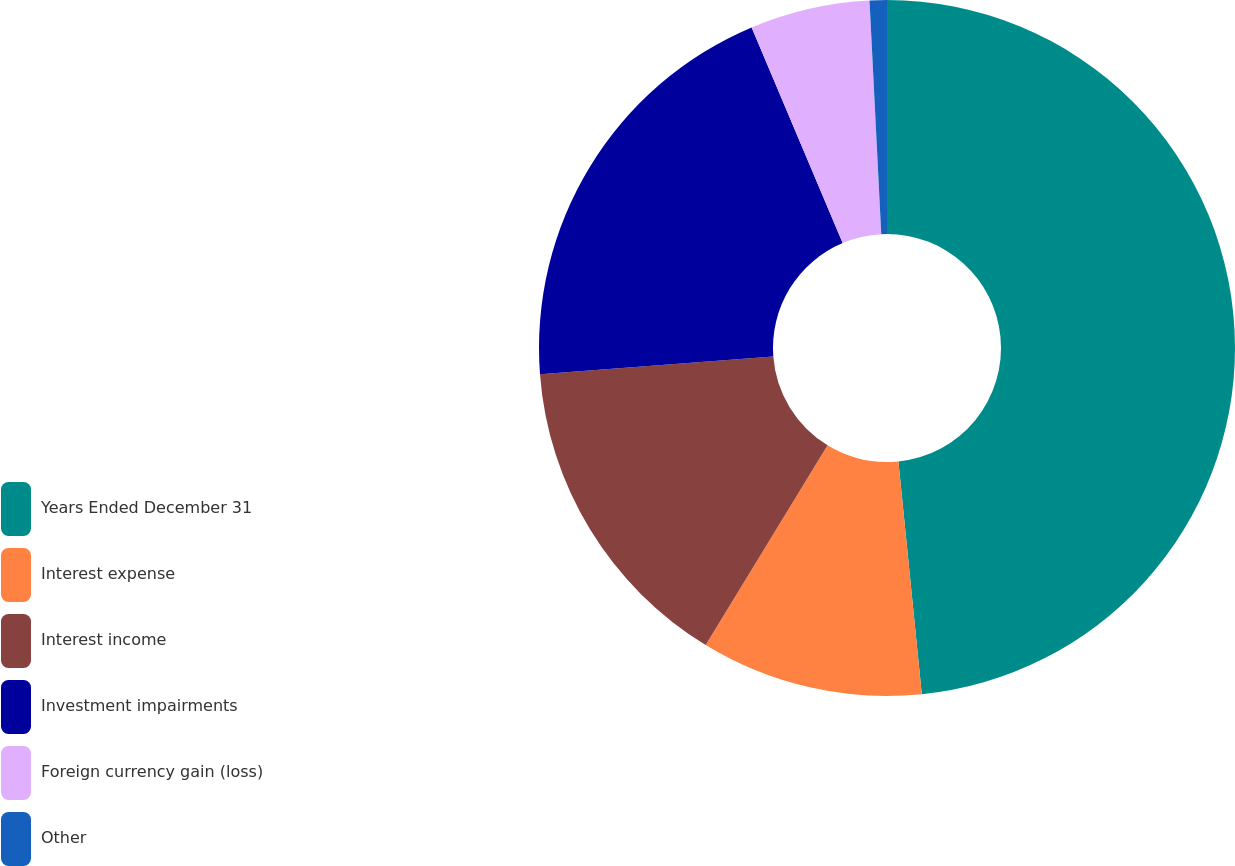<chart> <loc_0><loc_0><loc_500><loc_500><pie_chart><fcel>Years Ended December 31<fcel>Interest expense<fcel>Interest income<fcel>Investment impairments<fcel>Foreign currency gain (loss)<fcel>Other<nl><fcel>48.41%<fcel>10.32%<fcel>15.08%<fcel>19.84%<fcel>5.56%<fcel>0.8%<nl></chart> 